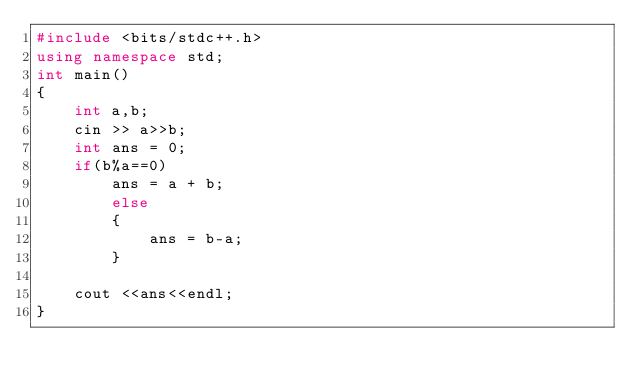Convert code to text. <code><loc_0><loc_0><loc_500><loc_500><_C++_>#include <bits/stdc++.h>
using namespace std;
int main()
{
    int a,b;
    cin >> a>>b;
    int ans = 0;
    if(b%a==0)
        ans = a + b;
        else
        {
            ans = b-a;
        }
        
    cout <<ans<<endl;
}
</code> 